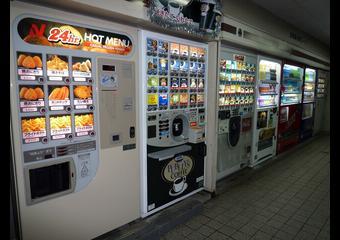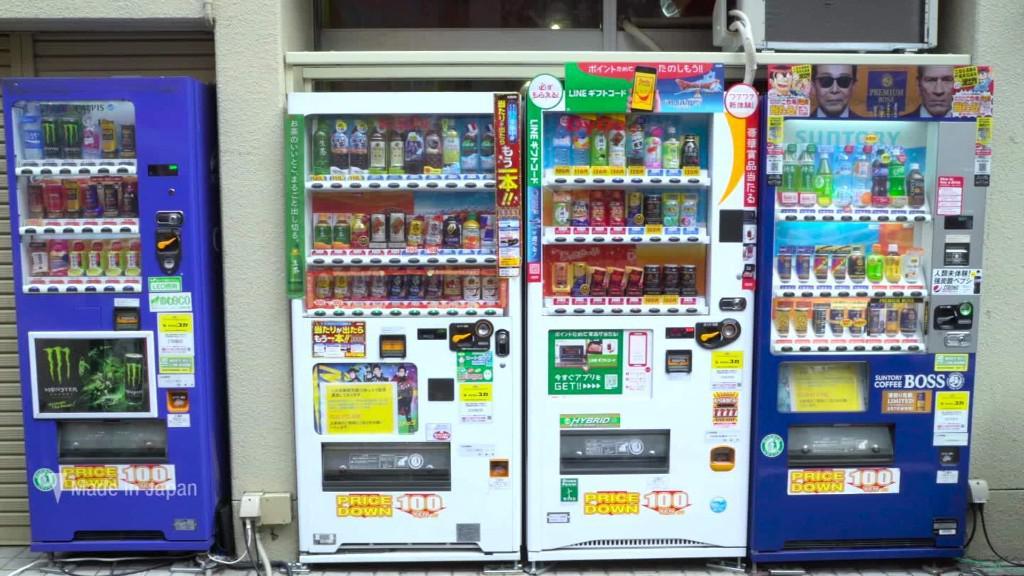The first image is the image on the left, the second image is the image on the right. Considering the images on both sides, is "One image shows blue vending machines flanking two other machines in a row facing the camera head-on." valid? Answer yes or no. Yes. The first image is the image on the left, the second image is the image on the right. For the images shown, is this caption "Four machines are lined up in the image on the right." true? Answer yes or no. Yes. 